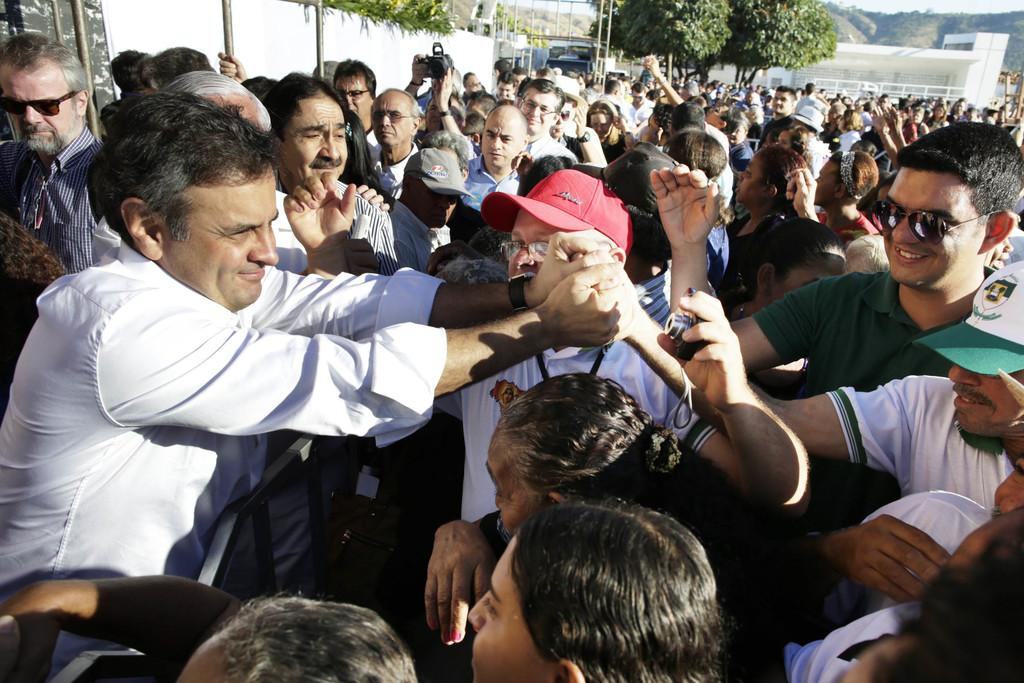What are the people in the image doing? The people in the image are standing on the road. What are some of the people holding? Some of the people are holding cameras. What can be seen in the background of the image? In the background, there are poles, trees, wells, hills, and the sky. What type of cub can be seen playing with powder in the image? There is no cub or powder present in the image. Is there a train visible in the background of the image? No, there is no train visible in the background of the image. 